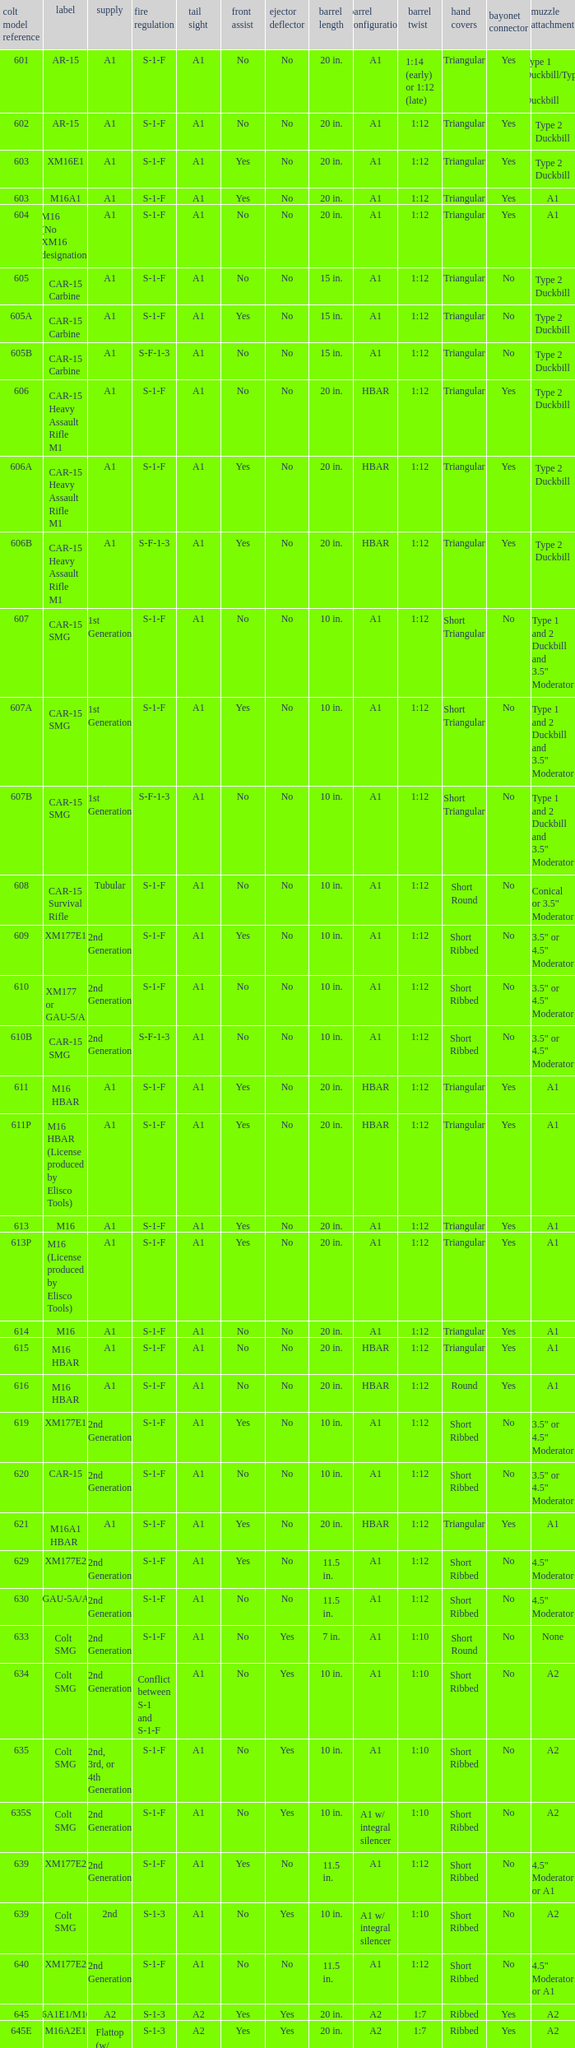What is the rear sight in the Cole model no. 735? A1 or A2. 